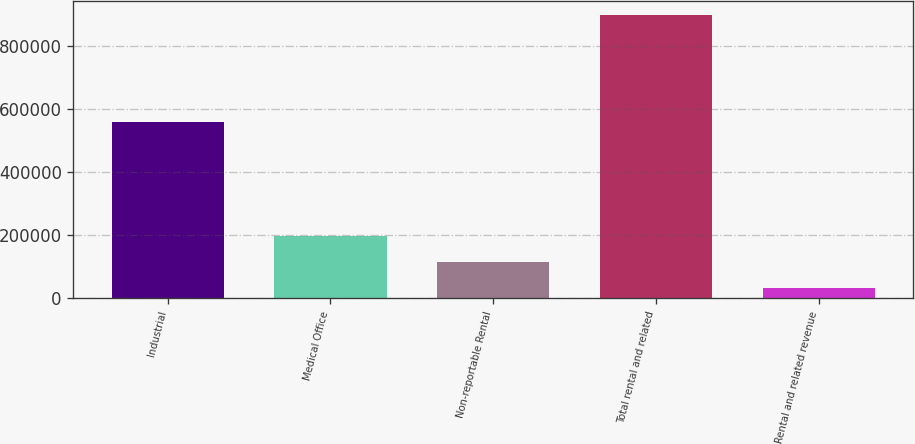Convert chart. <chart><loc_0><loc_0><loc_500><loc_500><bar_chart><fcel>Industrial<fcel>Medical Office<fcel>Non-reportable Rental<fcel>Total rental and related<fcel>Rental and related revenue<nl><fcel>556903<fcel>195762<fcel>114156<fcel>897672<fcel>32549<nl></chart> 